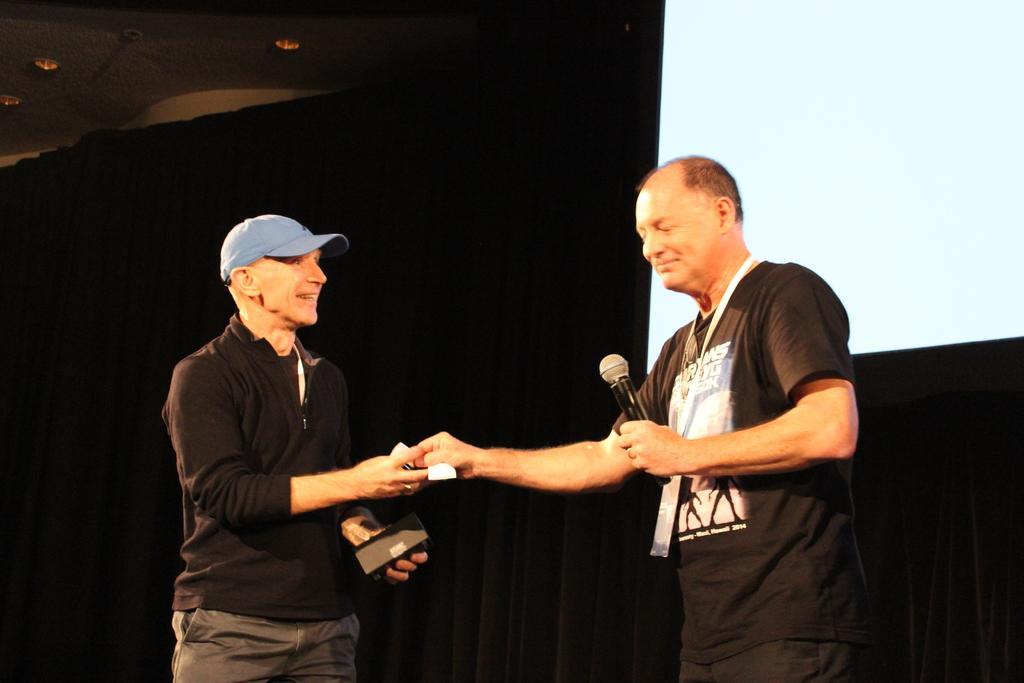Please provide a concise description of this image. In this picture there is a man who is wearing cap, black t-shirt and trouser. He is holding black box. On the right there is a person who is wearing t-shirt, card and trouser. He is holding a mic. He is standing near to the projector screen. On the top left corner we can see lights. 